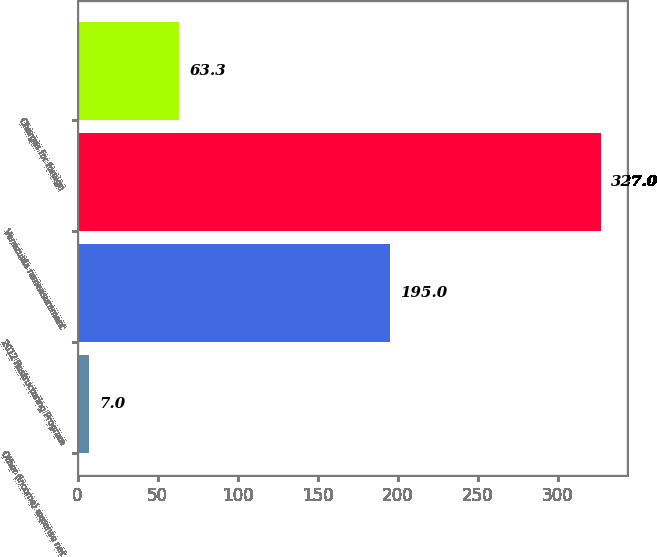<chart> <loc_0><loc_0><loc_500><loc_500><bar_chart><fcel>Other (income) expense net<fcel>2012 Restructuring Program<fcel>Venezuela remeasurement<fcel>Charges for foreign<nl><fcel>7<fcel>195<fcel>327<fcel>63.3<nl></chart> 